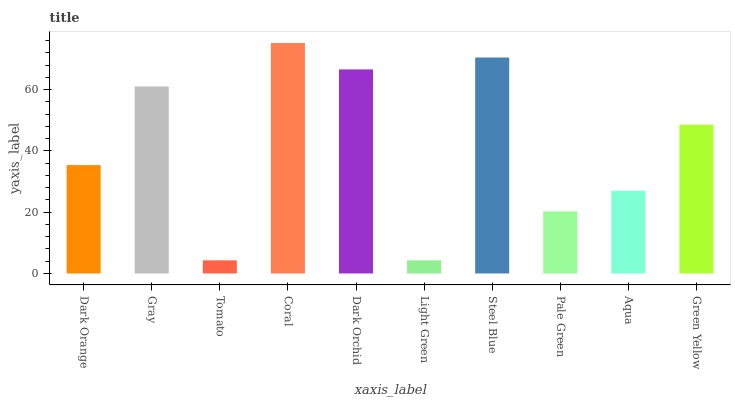Is Light Green the minimum?
Answer yes or no. Yes. Is Coral the maximum?
Answer yes or no. Yes. Is Gray the minimum?
Answer yes or no. No. Is Gray the maximum?
Answer yes or no. No. Is Gray greater than Dark Orange?
Answer yes or no. Yes. Is Dark Orange less than Gray?
Answer yes or no. Yes. Is Dark Orange greater than Gray?
Answer yes or no. No. Is Gray less than Dark Orange?
Answer yes or no. No. Is Green Yellow the high median?
Answer yes or no. Yes. Is Dark Orange the low median?
Answer yes or no. Yes. Is Gray the high median?
Answer yes or no. No. Is Steel Blue the low median?
Answer yes or no. No. 